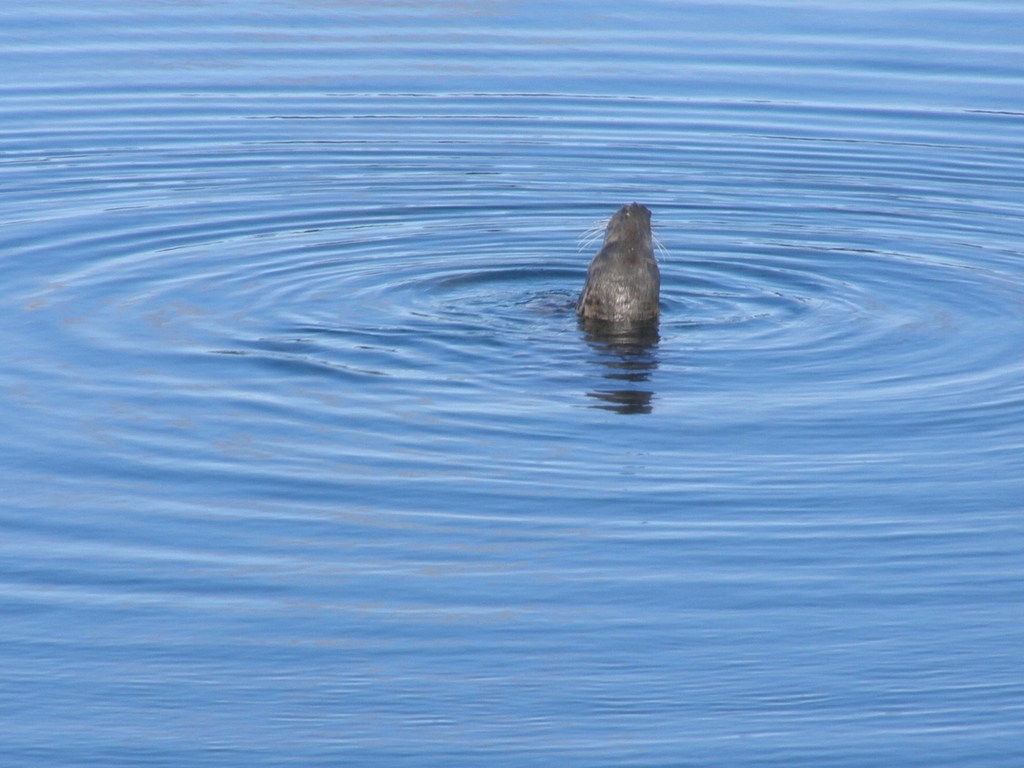What can be seen in the background of the image? A. Mountains in the distance B. Buildings on the shore C. Clouds in the sky D. Ripples on the water surface Answer with the option's letter from the given choices directly. The most prominent feature in the background of the image is D. Ripples on the water surface, which are seen surrounding a focal point that appears to be a marine animal's head emerging from the water. The ripples form concentric circles, giving a sense of motion on the otherwise calm water surface. There are no buildings, mountains, or distinctive clouds in sight; the focus is purely on the simplicity and serenity of the water and the solitary figure that has broken its stillness. 